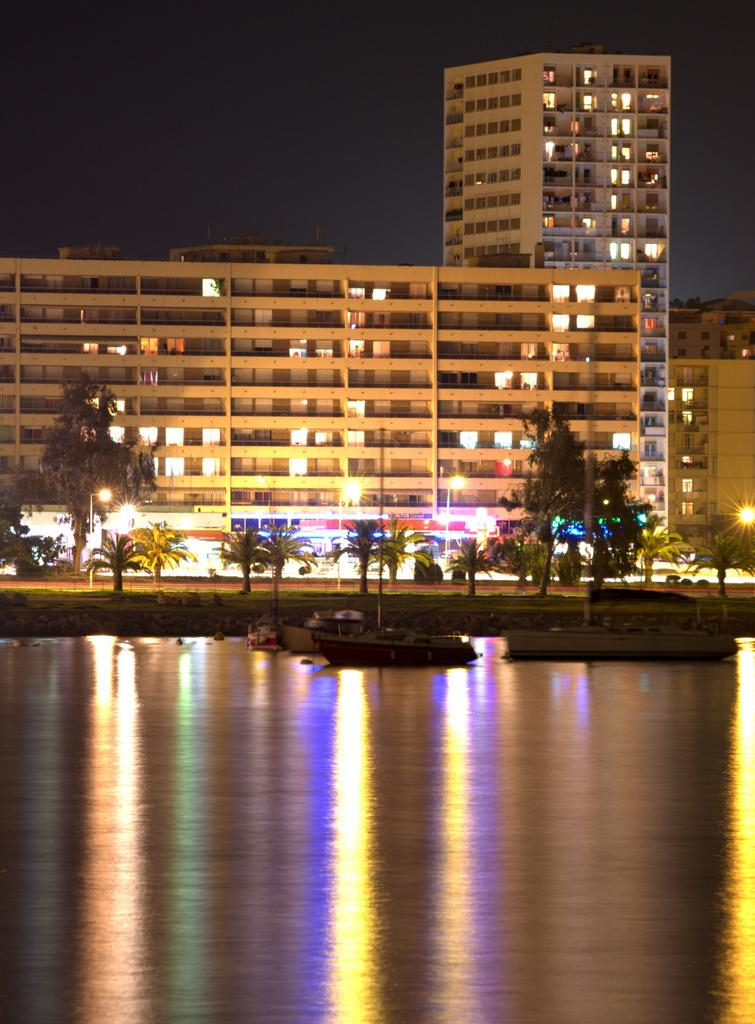What is the primary element in the image? There is water in the image. What can be seen floating on the water? There are boats in the water. What type of natural scenery is visible in the background of the image? There are trees, grass, and buildings in the background of the image. What additional features can be seen in the background? There are lights and the sky visible in the background of the image. What type of beast is hiding in the pocket of the person in the image? There is no person or pocket present in the image, so it is not possible to determine if a beast is hiding in a pocket. 